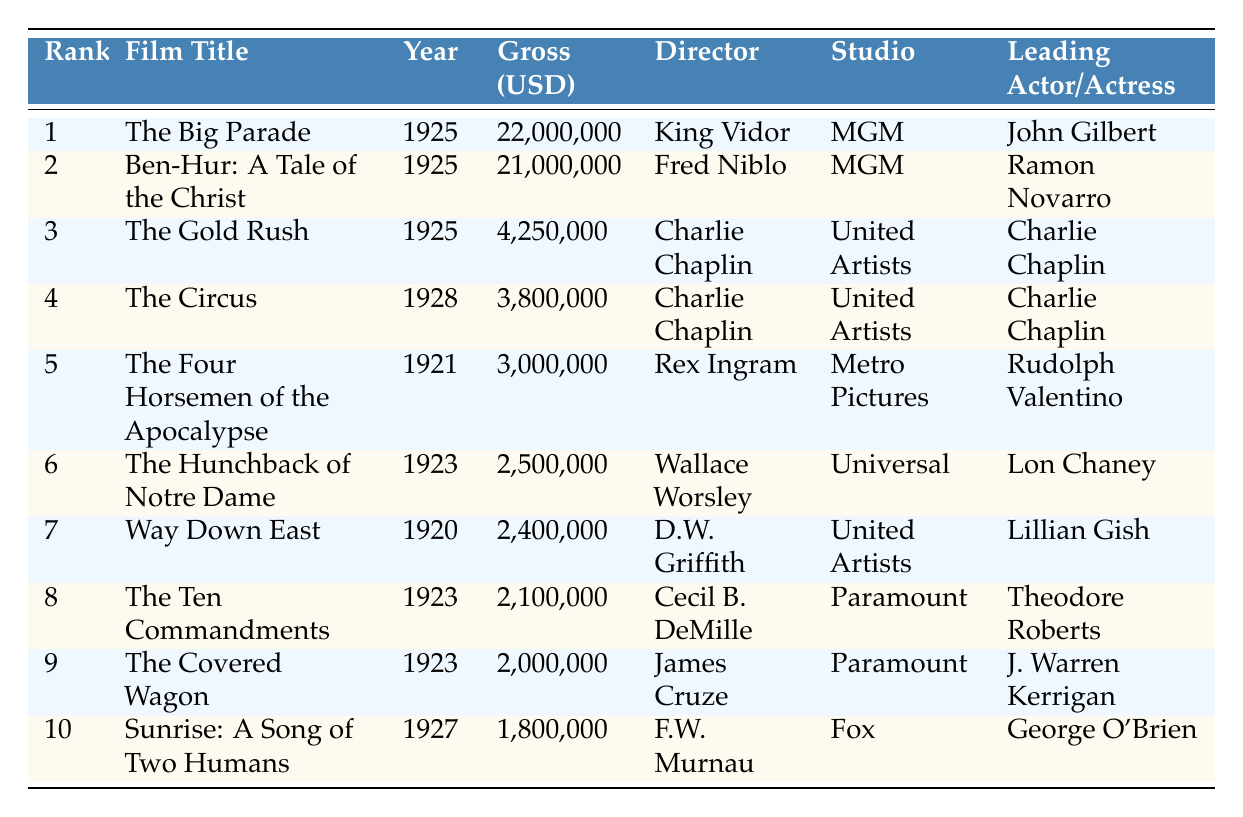What is the highest-grossing silent film of the 1920s? The table shows that the highest-grossing silent film listed is "The Big Parade" with a gross of 22,000,000 USD in 1925.
Answer: The Big Parade Which film had the second highest gross? Referring to the table, the film with the second highest gross is "Ben-Hur: A Tale of the Christ," which earned 21,000,000 USD, also in 1925.
Answer: Ben-Hur: A Tale of the Christ How much more did "The Big Parade" gross compared to "The Gold Rush"? "The Big Parade" grossed 22,000,000 USD while "The Gold Rush" grossed 4,250,000 USD. Calculating the difference: 22,000,000 - 4,250,000 = 17,750,000 USD.
Answer: 17,750,000 Is "The Circus" the only film directed by Charlie Chaplin on this list? The table indicates that both "The Gold Rush" and "The Circus" were directed by Charlie Chaplin. Therefore, it is not the only film directed by him.
Answer: No What is the total gross of the top three films listed? The top three films are "The Big Parade" (22,000,000 USD), "Ben-Hur" (21,000,000 USD), and "The Gold Rush" (4,250,000 USD). Adding these amounts: 22,000,000 + 21,000,000 + 4,250,000 = 47,250,000 USD.
Answer: 47,250,000 Which studio produced the most films in the top 10? The table shows that MGM produced 2 films: "The Big Parade" and "Ben-Hur," while United Artists also produced 2 films: "The Gold Rush" and "The Circus." Thus, there is no studio that clearly stands out with more films.
Answer: None What was the gross of the film "Way Down East"? The table lists "Way Down East" with a gross of 2,400,000 USD, confirming the specific revenue generated by the film.
Answer: 2,400,000 Which film had the lowest gross in this list? The film with the lowest gross listed is "Sunrise: A Song of Two Humans," which achieved a gross of 1,800,000 USD in 1927.
Answer: Sunrise: A Song of Two Humans 